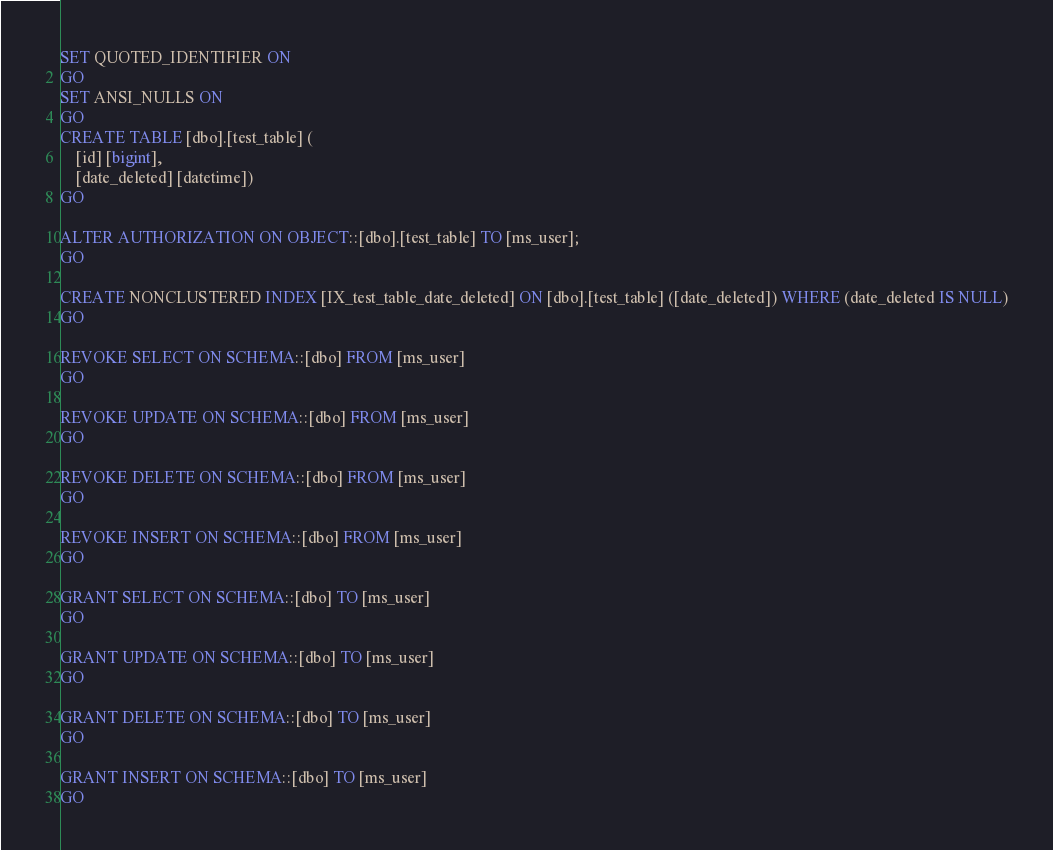Convert code to text. <code><loc_0><loc_0><loc_500><loc_500><_SQL_>SET QUOTED_IDENTIFIER ON
GO
SET ANSI_NULLS ON
GO
CREATE TABLE [dbo].[test_table] (
    [id] [bigint],
    [date_deleted] [datetime])
GO

ALTER AUTHORIZATION ON OBJECT::[dbo].[test_table] TO [ms_user];    
GO

CREATE NONCLUSTERED INDEX [IX_test_table_date_deleted] ON [dbo].[test_table] ([date_deleted]) WHERE (date_deleted IS NULL)
GO

REVOKE SELECT ON SCHEMA::[dbo] FROM [ms_user]
GO

REVOKE UPDATE ON SCHEMA::[dbo] FROM [ms_user]
GO

REVOKE DELETE ON SCHEMA::[dbo] FROM [ms_user]
GO

REVOKE INSERT ON SCHEMA::[dbo] FROM [ms_user]
GO

GRANT SELECT ON SCHEMA::[dbo] TO [ms_user]
GO

GRANT UPDATE ON SCHEMA::[dbo] TO [ms_user]
GO

GRANT DELETE ON SCHEMA::[dbo] TO [ms_user]
GO

GRANT INSERT ON SCHEMA::[dbo] TO [ms_user]
GO</code> 